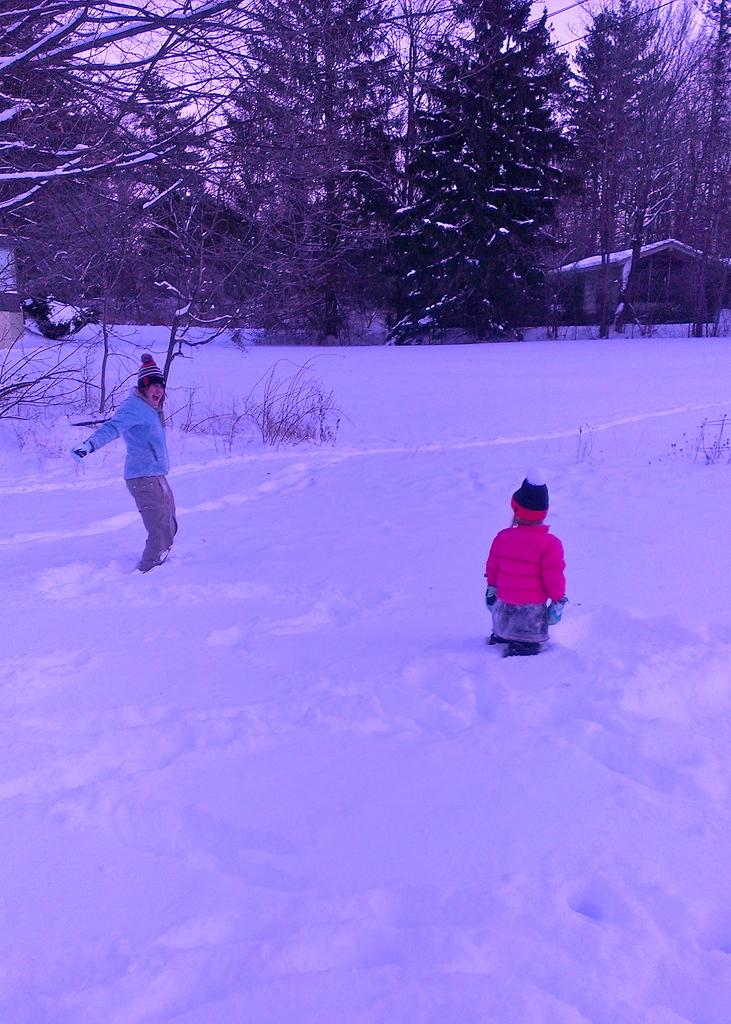How many people are in the image? There are two persons in the image. What is the setting of the image? The persons are standing in the snow. Can you describe the clothing of one of the persons? One person is wearing a cap, and the other person is wearing a pink jacket. What can be seen in the background of the image? There is a group of trees and a building in the background of the image. Can you see any stamps on the persons' clothing in the image? There are no stamps visible on the persons' clothing in the image. Is there a lake visible in the image? There is no lake present in the image; it features two persons standing in the snow with a background of trees and a building. 